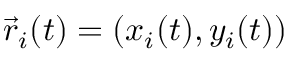<formula> <loc_0><loc_0><loc_500><loc_500>\vec { r } _ { i } ( t ) = ( x _ { i } ( t ) , y _ { i } ( t ) )</formula> 